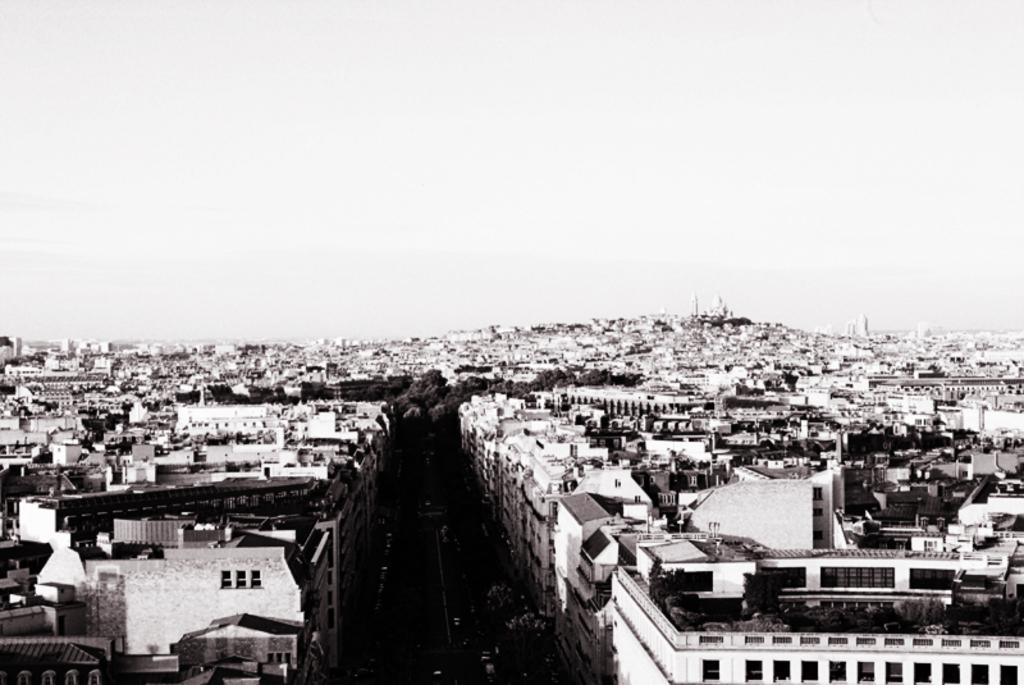What type of structures can be seen in the image? There are buildings in the image. What other natural elements are present in the image? There are trees in the image. What is the purpose of the road in the image? The road in the image is likely for transportation purposes. Can you describe the sky in the image? The sky is clear in the image. Where is the queen sitting in the image? There is no queen present in the image. Can you tell me how many airplanes are parked at the airport in the image? There is no airport present in the image. 